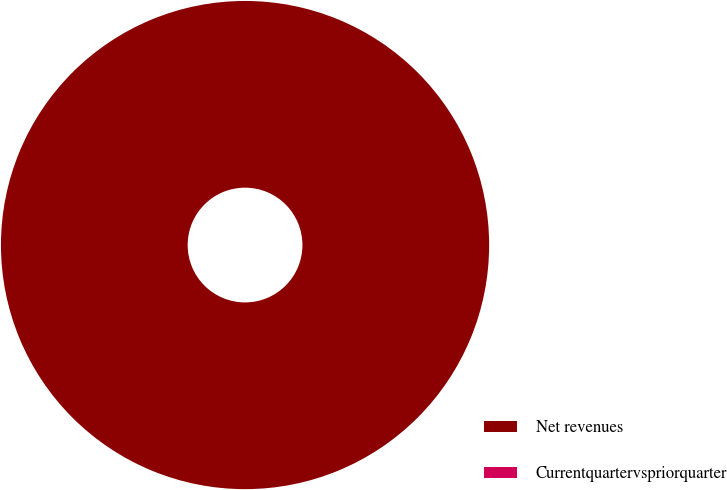<chart> <loc_0><loc_0><loc_500><loc_500><pie_chart><fcel>Net revenues<fcel>Currentquartervspriorquarter<nl><fcel>100.0%<fcel>0.0%<nl></chart> 